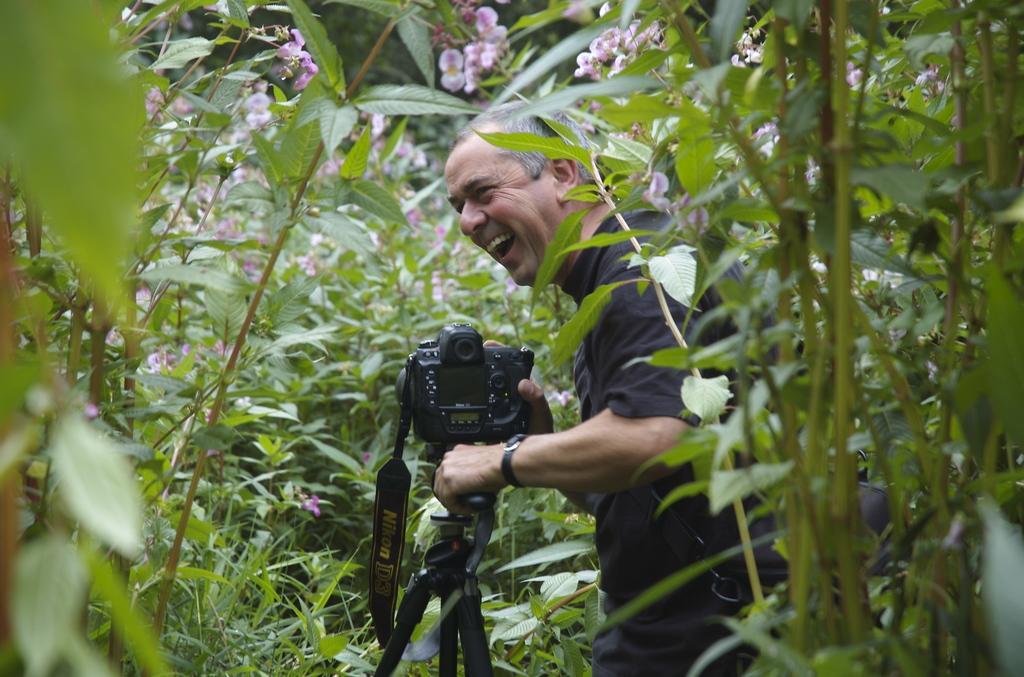In one or two sentences, can you explain what this image depicts? In this picture there is a man standing and laughing, holding a camera in his hands. Around him there are some trees and plants here. 